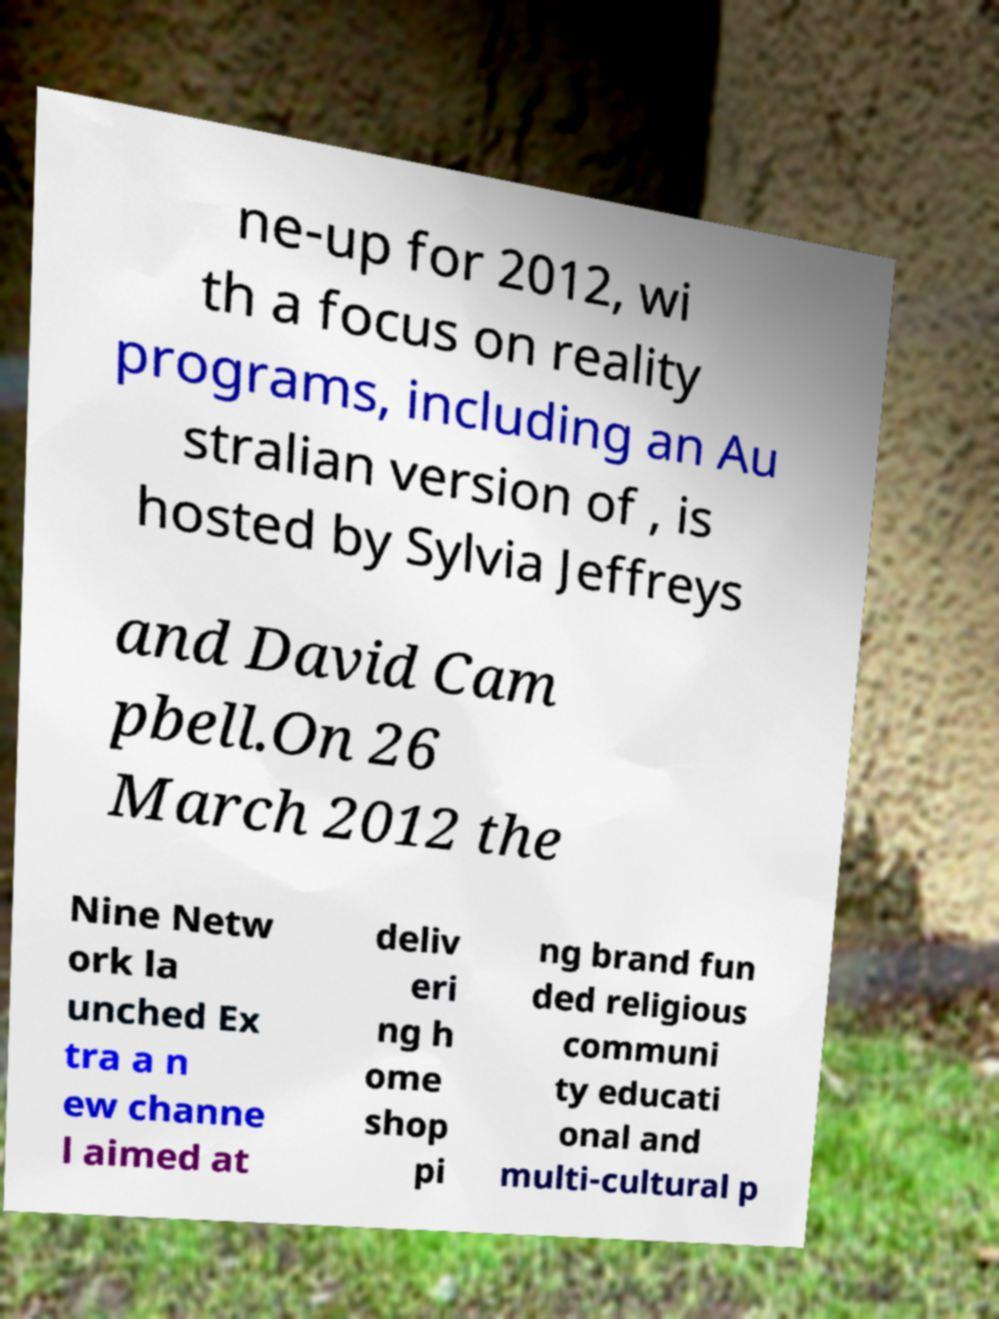Can you read and provide the text displayed in the image?This photo seems to have some interesting text. Can you extract and type it out for me? ne-up for 2012, wi th a focus on reality programs, including an Au stralian version of , is hosted by Sylvia Jeffreys and David Cam pbell.On 26 March 2012 the Nine Netw ork la unched Ex tra a n ew channe l aimed at deliv eri ng h ome shop pi ng brand fun ded religious communi ty educati onal and multi-cultural p 